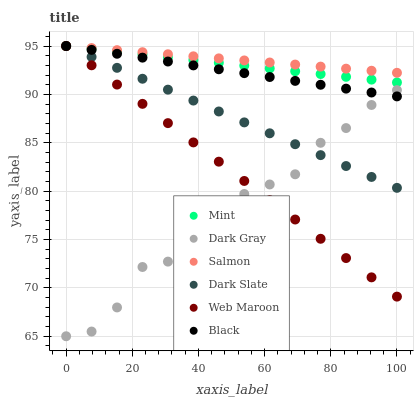Does Dark Gray have the minimum area under the curve?
Answer yes or no. Yes. Does Salmon have the maximum area under the curve?
Answer yes or no. Yes. Does Salmon have the minimum area under the curve?
Answer yes or no. No. Does Dark Gray have the maximum area under the curve?
Answer yes or no. No. Is Black the smoothest?
Answer yes or no. Yes. Is Dark Gray the roughest?
Answer yes or no. Yes. Is Salmon the smoothest?
Answer yes or no. No. Is Salmon the roughest?
Answer yes or no. No. Does Dark Gray have the lowest value?
Answer yes or no. Yes. Does Salmon have the lowest value?
Answer yes or no. No. Does Mint have the highest value?
Answer yes or no. Yes. Does Dark Gray have the highest value?
Answer yes or no. No. Is Dark Gray less than Mint?
Answer yes or no. Yes. Is Salmon greater than Dark Gray?
Answer yes or no. Yes. Does Dark Slate intersect Salmon?
Answer yes or no. Yes. Is Dark Slate less than Salmon?
Answer yes or no. No. Is Dark Slate greater than Salmon?
Answer yes or no. No. Does Dark Gray intersect Mint?
Answer yes or no. No. 